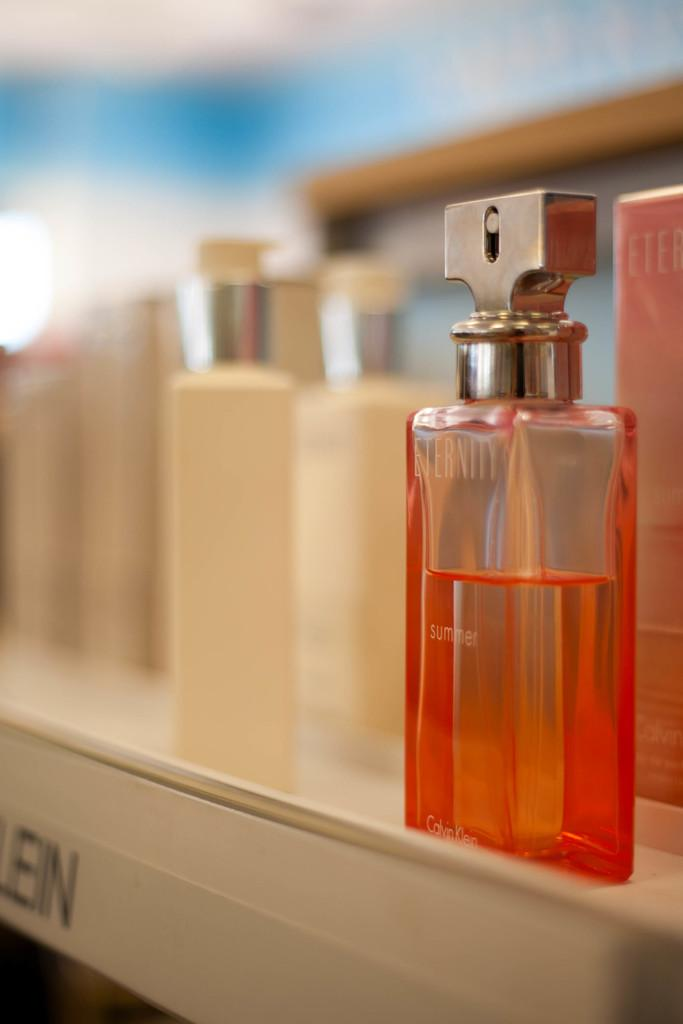<image>
Share a concise interpretation of the image provided. a cologne that says eternity on the front 